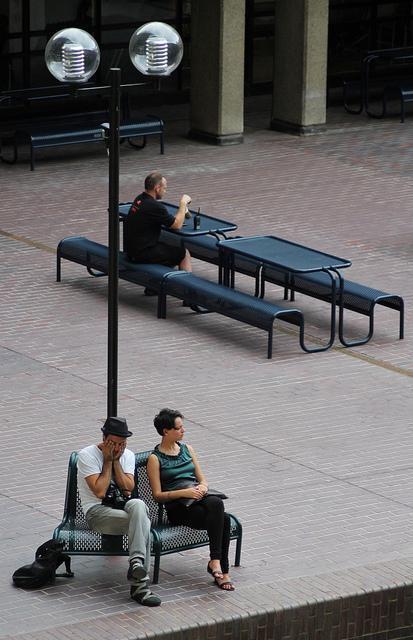How many benches are there?
Give a very brief answer. 3. How many people are there?
Give a very brief answer. 3. 